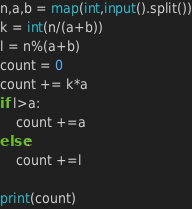Convert code to text. <code><loc_0><loc_0><loc_500><loc_500><_Python_>n,a,b = map(int,input().split())
k = int(n/(a+b))
l = n%(a+b)
count = 0
count += k*a
if l>a:
    count +=a
else:
    count +=l

print(count)
</code> 